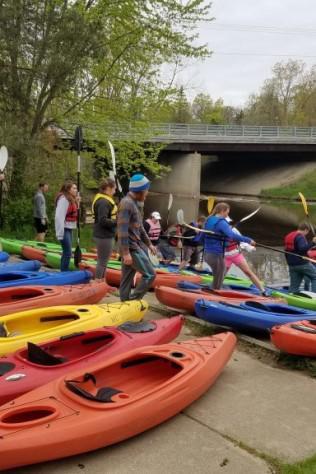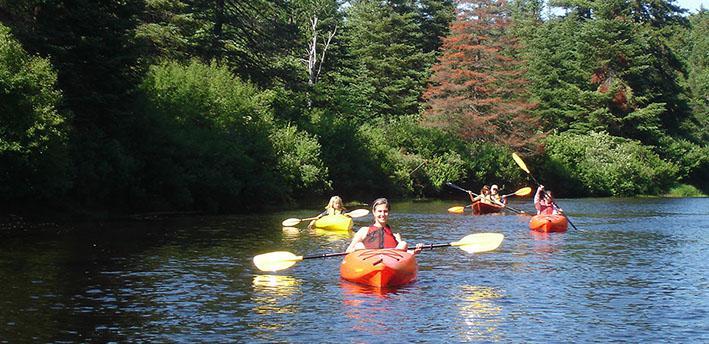The first image is the image on the left, the second image is the image on the right. For the images shown, is this caption "There is exactly one boat in the left image." true? Answer yes or no. No. 